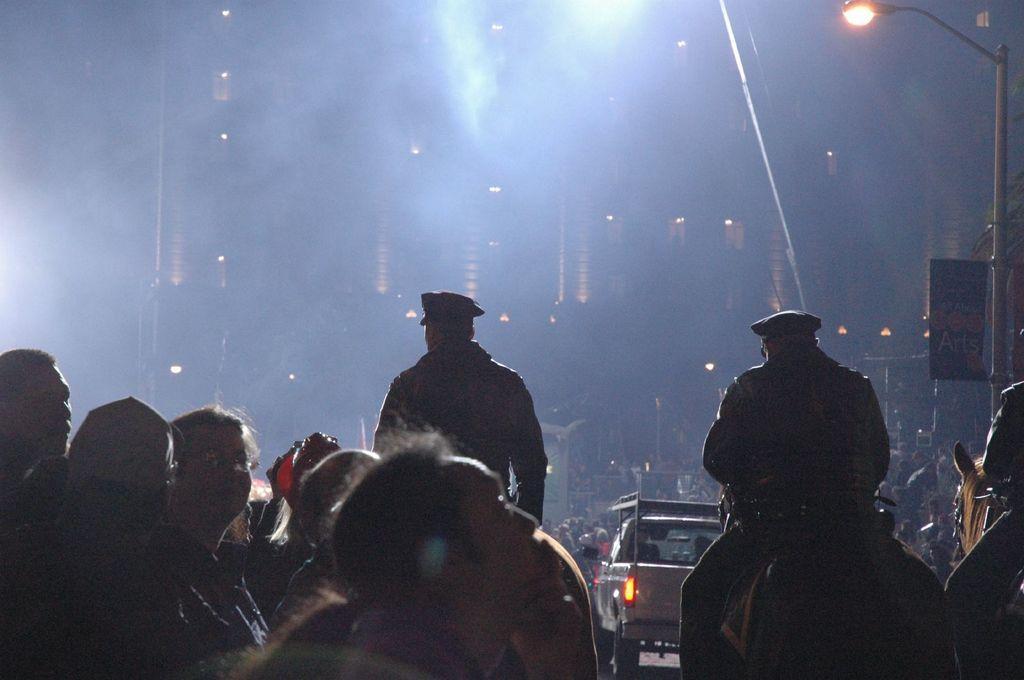In one or two sentences, can you explain what this image depicts? In this image there are some persons standing in the bottom of this image. There is one vehicle on the right side of this image and there is a current pole on the right side of this image and there are some buildings in the background. 